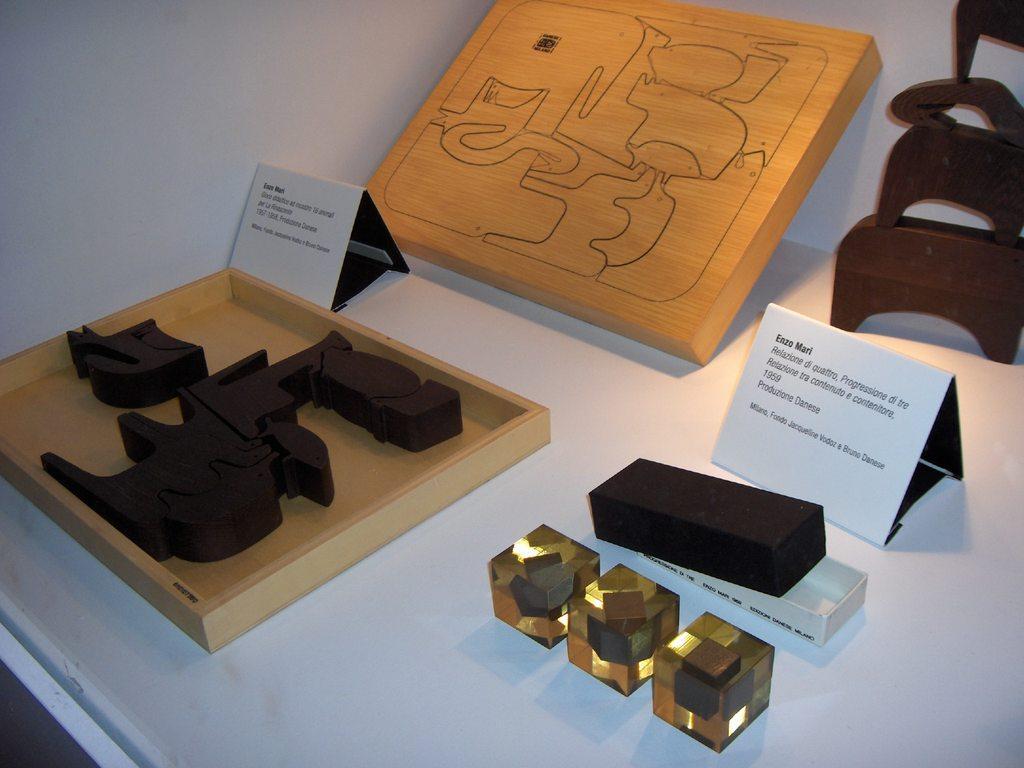In one or two sentences, can you explain what this image depicts? In this picture, we see a white table on which a wooden tray containing a black color object and the small white color boards with some text written are placed on the table. We see the cubes, a box in white and black color and a wooden board are placed. In the right top, we see an object in black color is placed on the table. In the background, we see a white wall. 